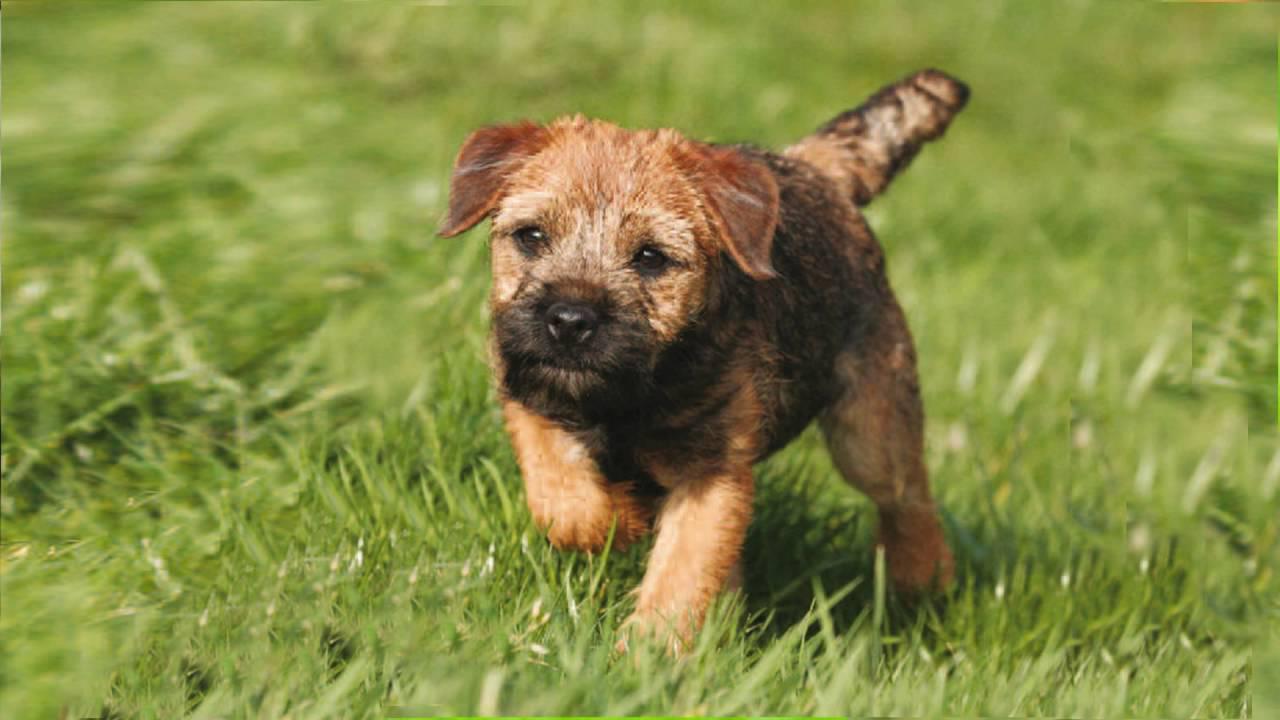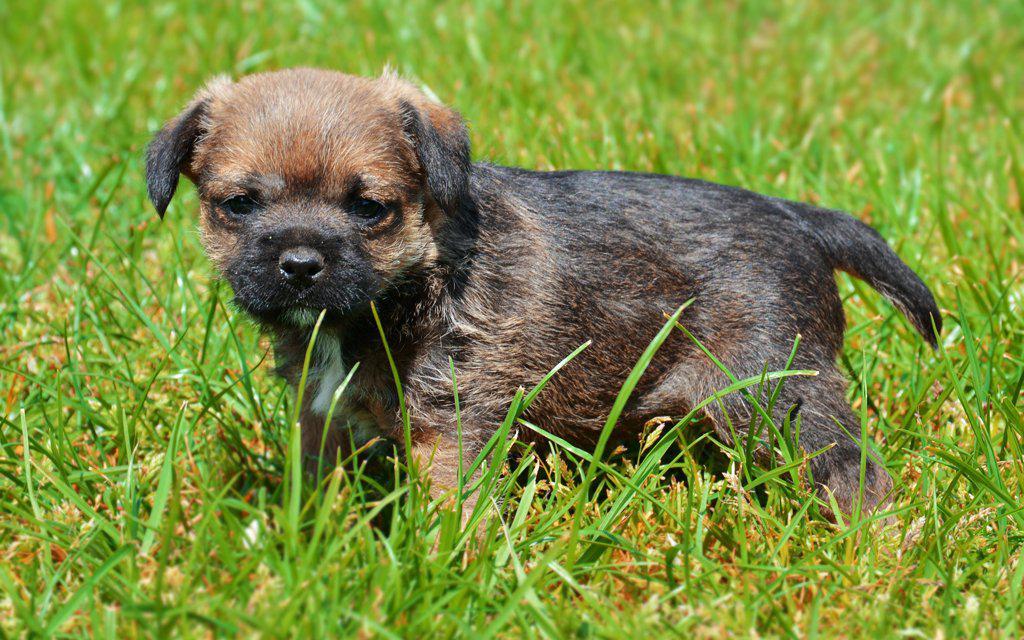The first image is the image on the left, the second image is the image on the right. For the images shown, is this caption "The dog in the image on the left has only three feet on the ground." true? Answer yes or no. Yes. 